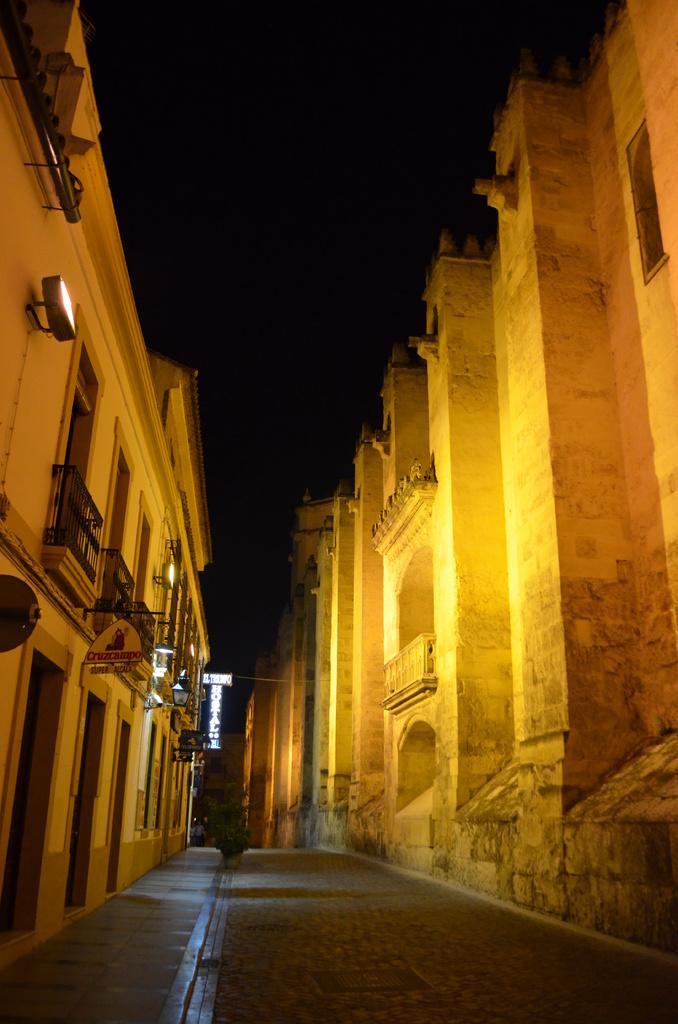In one or two sentences, can you explain what this image depicts? In the image there is a huge building on the left side and there is a fort on the right side, in between these two constructions there is a pavement. 